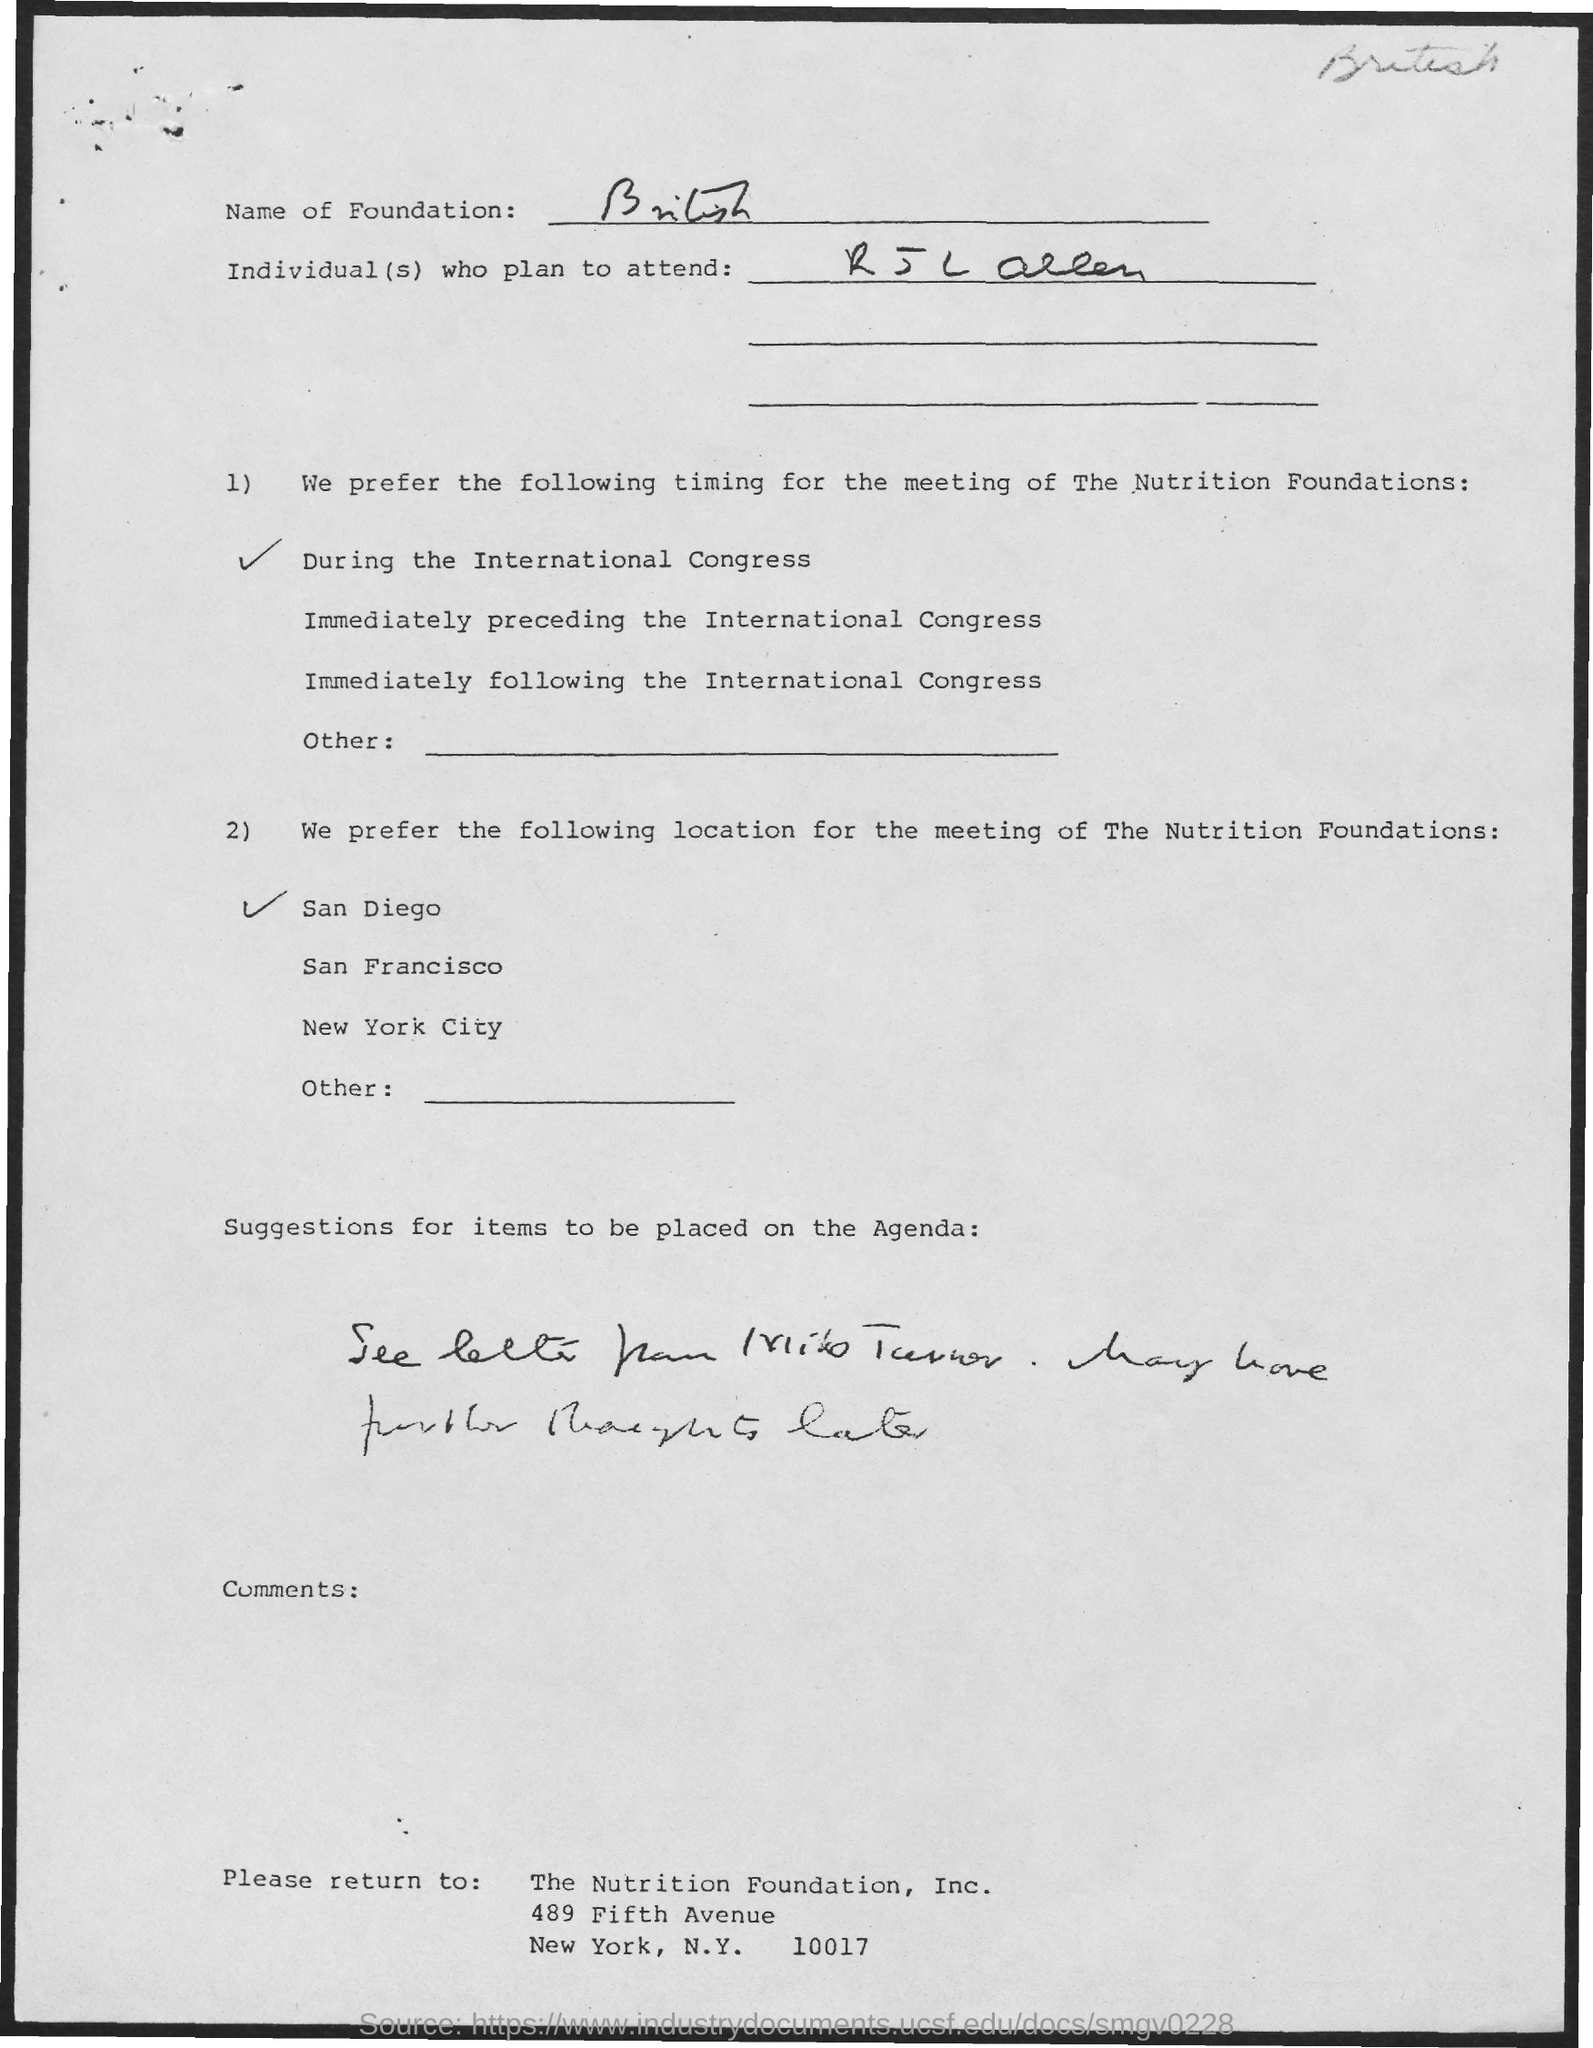List a handful of essential elements in this visual. It is the preferred location for the meeting to be held in San Diego. The zip code of the Nutrition Foundation, Inc. is 10017. The name of the foundation is British. The meeting of the Nutrition Foundations is scheduled to take place during the International Congress on Tuesday at 2 PM. 